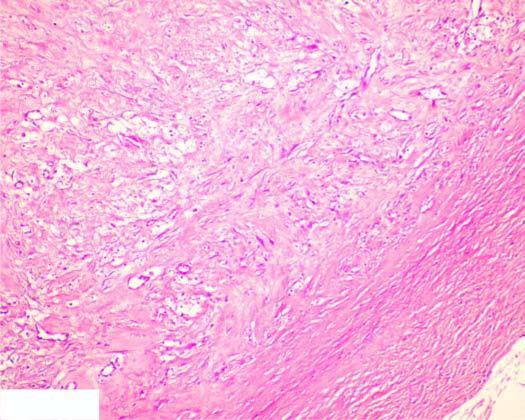s sectioned surface composed of mature collagenised fibrous connective tissue?
Answer the question using a single word or phrase. No 